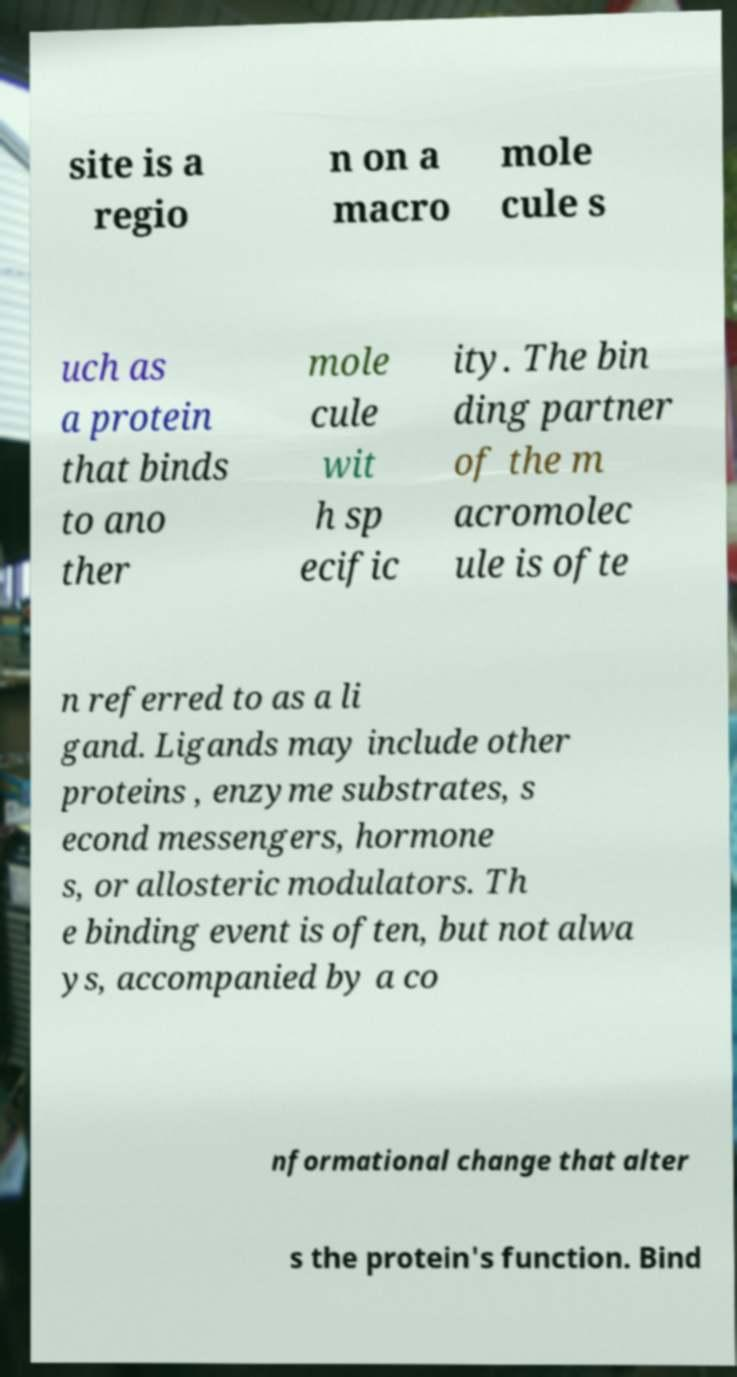Could you extract and type out the text from this image? site is a regio n on a macro mole cule s uch as a protein that binds to ano ther mole cule wit h sp ecific ity. The bin ding partner of the m acromolec ule is ofte n referred to as a li gand. Ligands may include other proteins , enzyme substrates, s econd messengers, hormone s, or allosteric modulators. Th e binding event is often, but not alwa ys, accompanied by a co nformational change that alter s the protein's function. Bind 